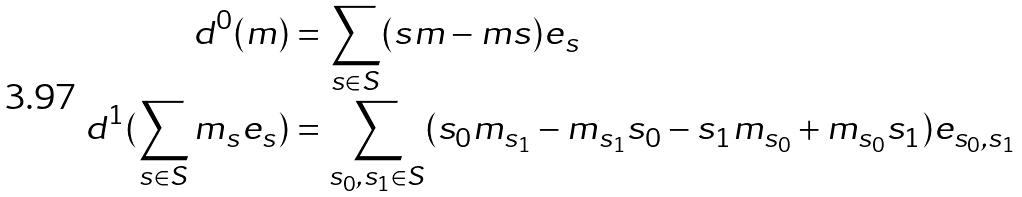<formula> <loc_0><loc_0><loc_500><loc_500>d ^ { 0 } ( m ) & = \sum _ { s \in S } ( s m - m s ) e _ { s } \\ d ^ { 1 } ( \sum _ { s \in S } m _ { s } e _ { s } ) & = \sum _ { s _ { 0 } , s _ { 1 } \in S } ( s _ { 0 } m _ { s _ { 1 } } - m _ { s _ { 1 } } s _ { 0 } - s _ { 1 } m _ { s _ { 0 } } + m _ { s _ { 0 } } s _ { 1 } ) e _ { s _ { 0 } , s _ { 1 } }</formula> 